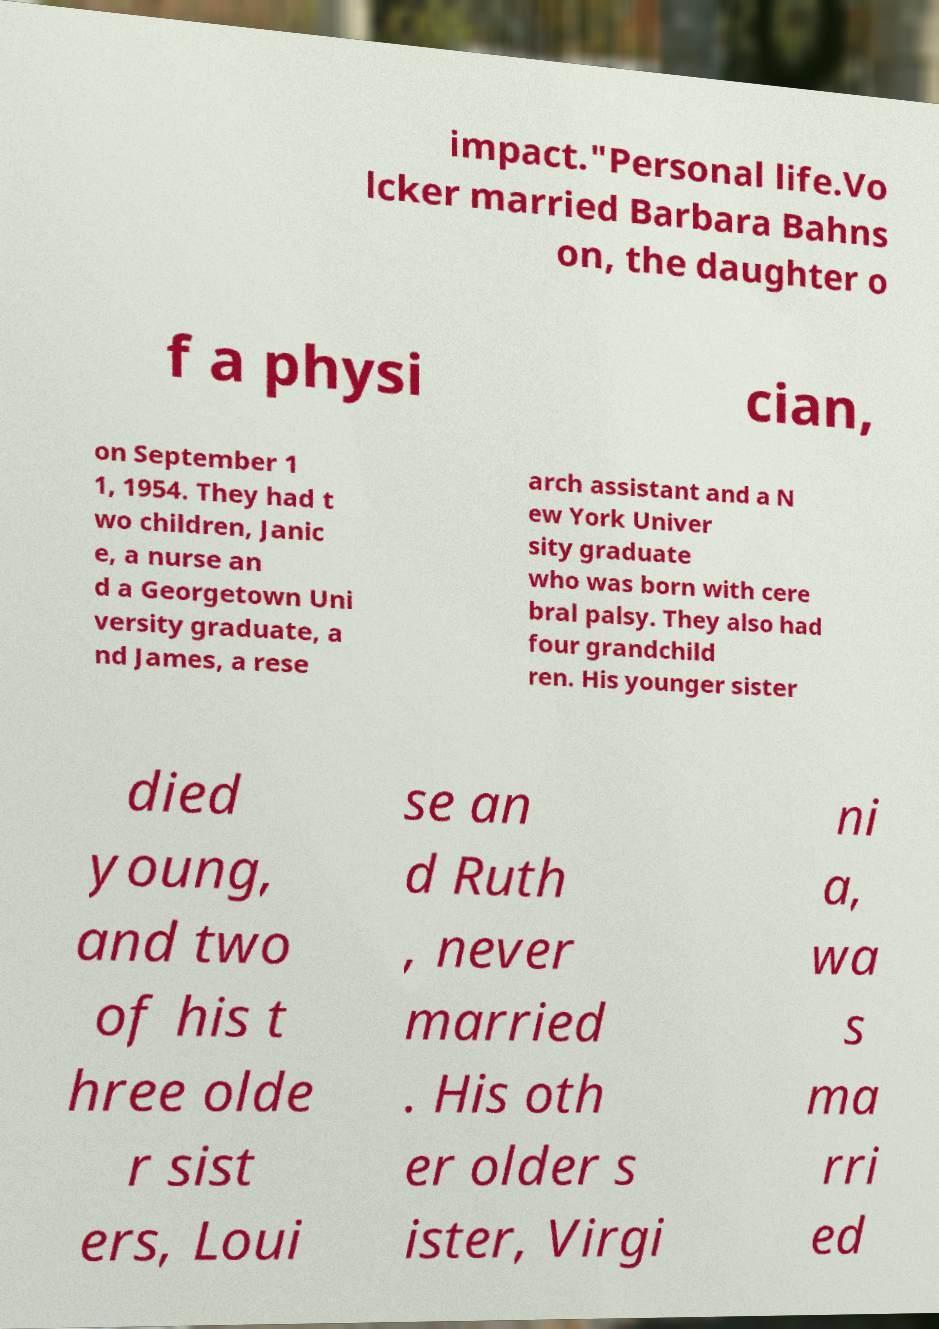For documentation purposes, I need the text within this image transcribed. Could you provide that? impact."Personal life.Vo lcker married Barbara Bahns on, the daughter o f a physi cian, on September 1 1, 1954. They had t wo children, Janic e, a nurse an d a Georgetown Uni versity graduate, a nd James, a rese arch assistant and a N ew York Univer sity graduate who was born with cere bral palsy. They also had four grandchild ren. His younger sister died young, and two of his t hree olde r sist ers, Loui se an d Ruth , never married . His oth er older s ister, Virgi ni a, wa s ma rri ed 